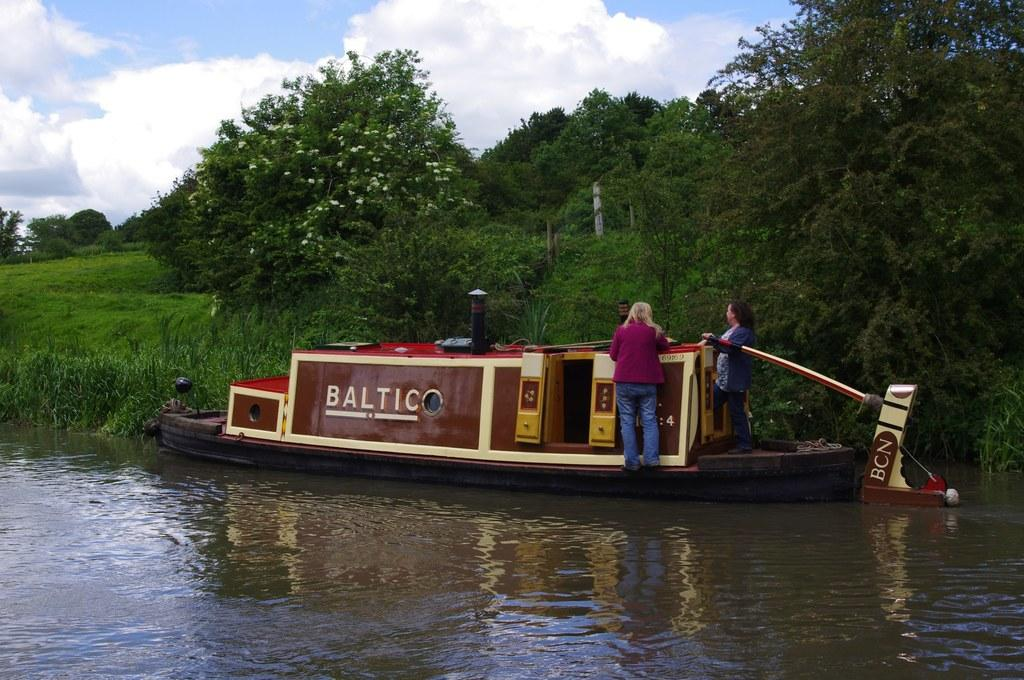How many women are in the image? There are two women standing in the image. What are the women wearing? The women are wearing clothes. What can be seen in the water in the image? There is a boat in the water. What type of vegetation is visible in the image? There is grass, plants, and trees visible in the image. What is the condition of the sky in the image? The sky is cloudy in the image. What type of police attraction can be seen in the image? There is no police attraction present in the image. Can you tell me how the women are flying in the image? The women are not flying in the image; they are standing on the ground. 